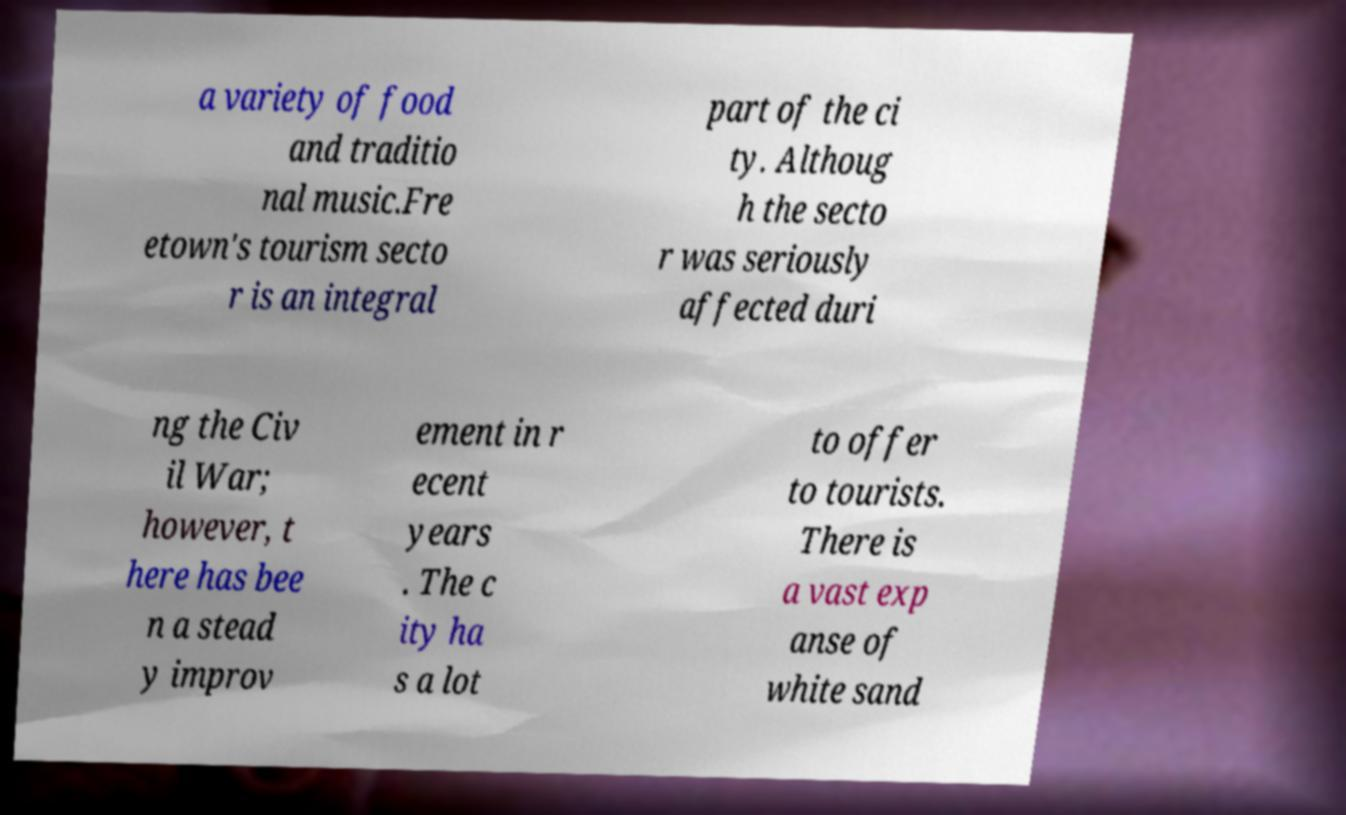What messages or text are displayed in this image? I need them in a readable, typed format. a variety of food and traditio nal music.Fre etown's tourism secto r is an integral part of the ci ty. Althoug h the secto r was seriously affected duri ng the Civ il War; however, t here has bee n a stead y improv ement in r ecent years . The c ity ha s a lot to offer to tourists. There is a vast exp anse of white sand 